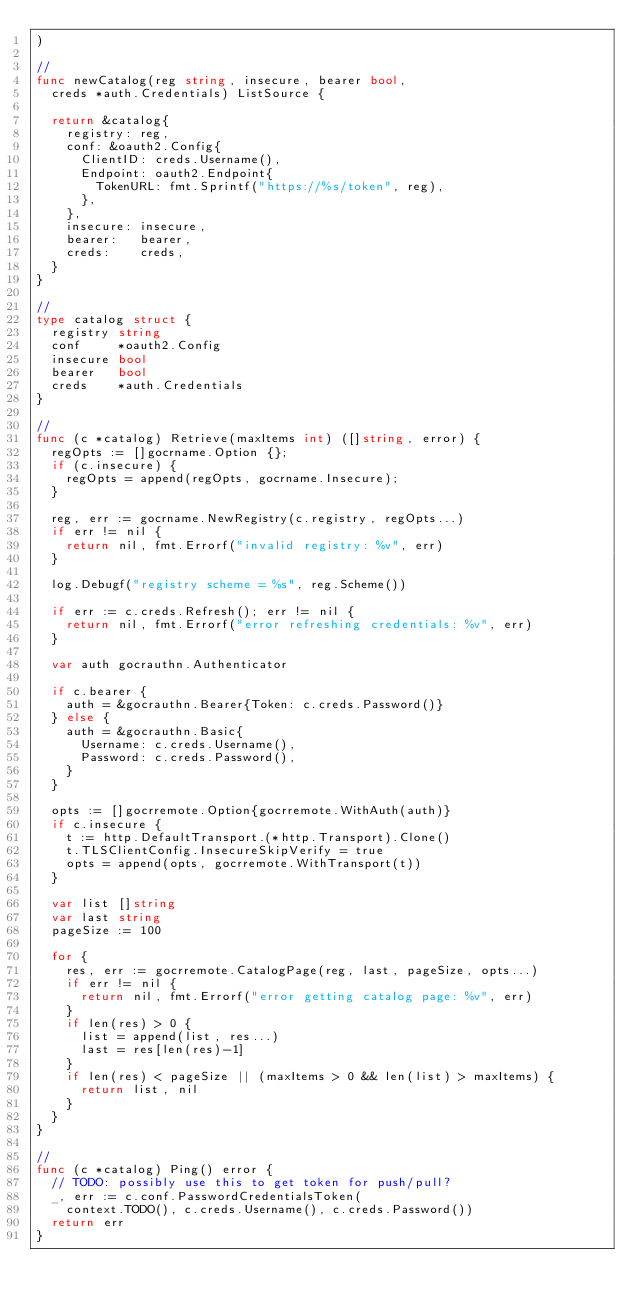<code> <loc_0><loc_0><loc_500><loc_500><_Go_>)

//
func newCatalog(reg string, insecure, bearer bool,
	creds *auth.Credentials) ListSource {

	return &catalog{
		registry: reg,
		conf: &oauth2.Config{
			ClientID: creds.Username(),
			Endpoint: oauth2.Endpoint{
				TokenURL: fmt.Sprintf("https://%s/token", reg),
			},
		},
		insecure: insecure,
		bearer:   bearer,
		creds:    creds,
	}
}

//
type catalog struct {
	registry string
	conf     *oauth2.Config
	insecure bool
	bearer   bool
	creds    *auth.Credentials
}

//
func (c *catalog) Retrieve(maxItems int) ([]string, error) {
	regOpts := []gocrname.Option {};
	if (c.insecure) {
		regOpts = append(regOpts, gocrname.Insecure);
	}

	reg, err := gocrname.NewRegistry(c.registry, regOpts...)
	if err != nil {
		return nil, fmt.Errorf("invalid registry: %v", err)
	}

	log.Debugf("registry scheme = %s", reg.Scheme())

	if err := c.creds.Refresh(); err != nil {
		return nil, fmt.Errorf("error refreshing credentials: %v", err)
	}

	var auth gocrauthn.Authenticator

	if c.bearer {
		auth = &gocrauthn.Bearer{Token: c.creds.Password()}
	} else {
		auth = &gocrauthn.Basic{
			Username: c.creds.Username(),
			Password: c.creds.Password(),
		}
	}

	opts := []gocrremote.Option{gocrremote.WithAuth(auth)}
	if c.insecure {
		t := http.DefaultTransport.(*http.Transport).Clone()
		t.TLSClientConfig.InsecureSkipVerify = true
		opts = append(opts, gocrremote.WithTransport(t))
	}

	var list []string
	var last string
	pageSize := 100

	for {
		res, err := gocrremote.CatalogPage(reg, last, pageSize, opts...)
		if err != nil {
			return nil, fmt.Errorf("error getting catalog page: %v", err)
		}
		if len(res) > 0 {
			list = append(list, res...)
			last = res[len(res)-1]
		}
		if len(res) < pageSize || (maxItems > 0 && len(list) > maxItems) {
			return list, nil
		}
	}
}

//
func (c *catalog) Ping() error {
	// TODO: possibly use this to get token for push/pull?
	_, err := c.conf.PasswordCredentialsToken(
		context.TODO(), c.creds.Username(), c.creds.Password())
	return err
}
</code> 